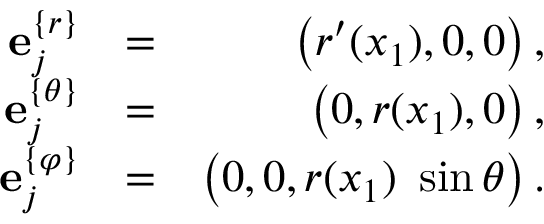Convert formula to latex. <formula><loc_0><loc_0><loc_500><loc_500>\begin{array} { r l r } { { e } _ { j } ^ { \{ r \} } } & { = } & { \left ( r ^ { \prime } ( x _ { 1 } ) , 0 , 0 \right ) , } \\ { { e } _ { j } ^ { \{ \theta \} } } & { = } & { \left ( 0 , r ( x _ { 1 } ) , 0 \right ) , } \\ { { e } _ { j } ^ { \{ \varphi \} } } & { = } & { \left ( 0 , 0 , r ( x _ { 1 } ) \ \sin \theta \right ) . } \end{array}</formula> 